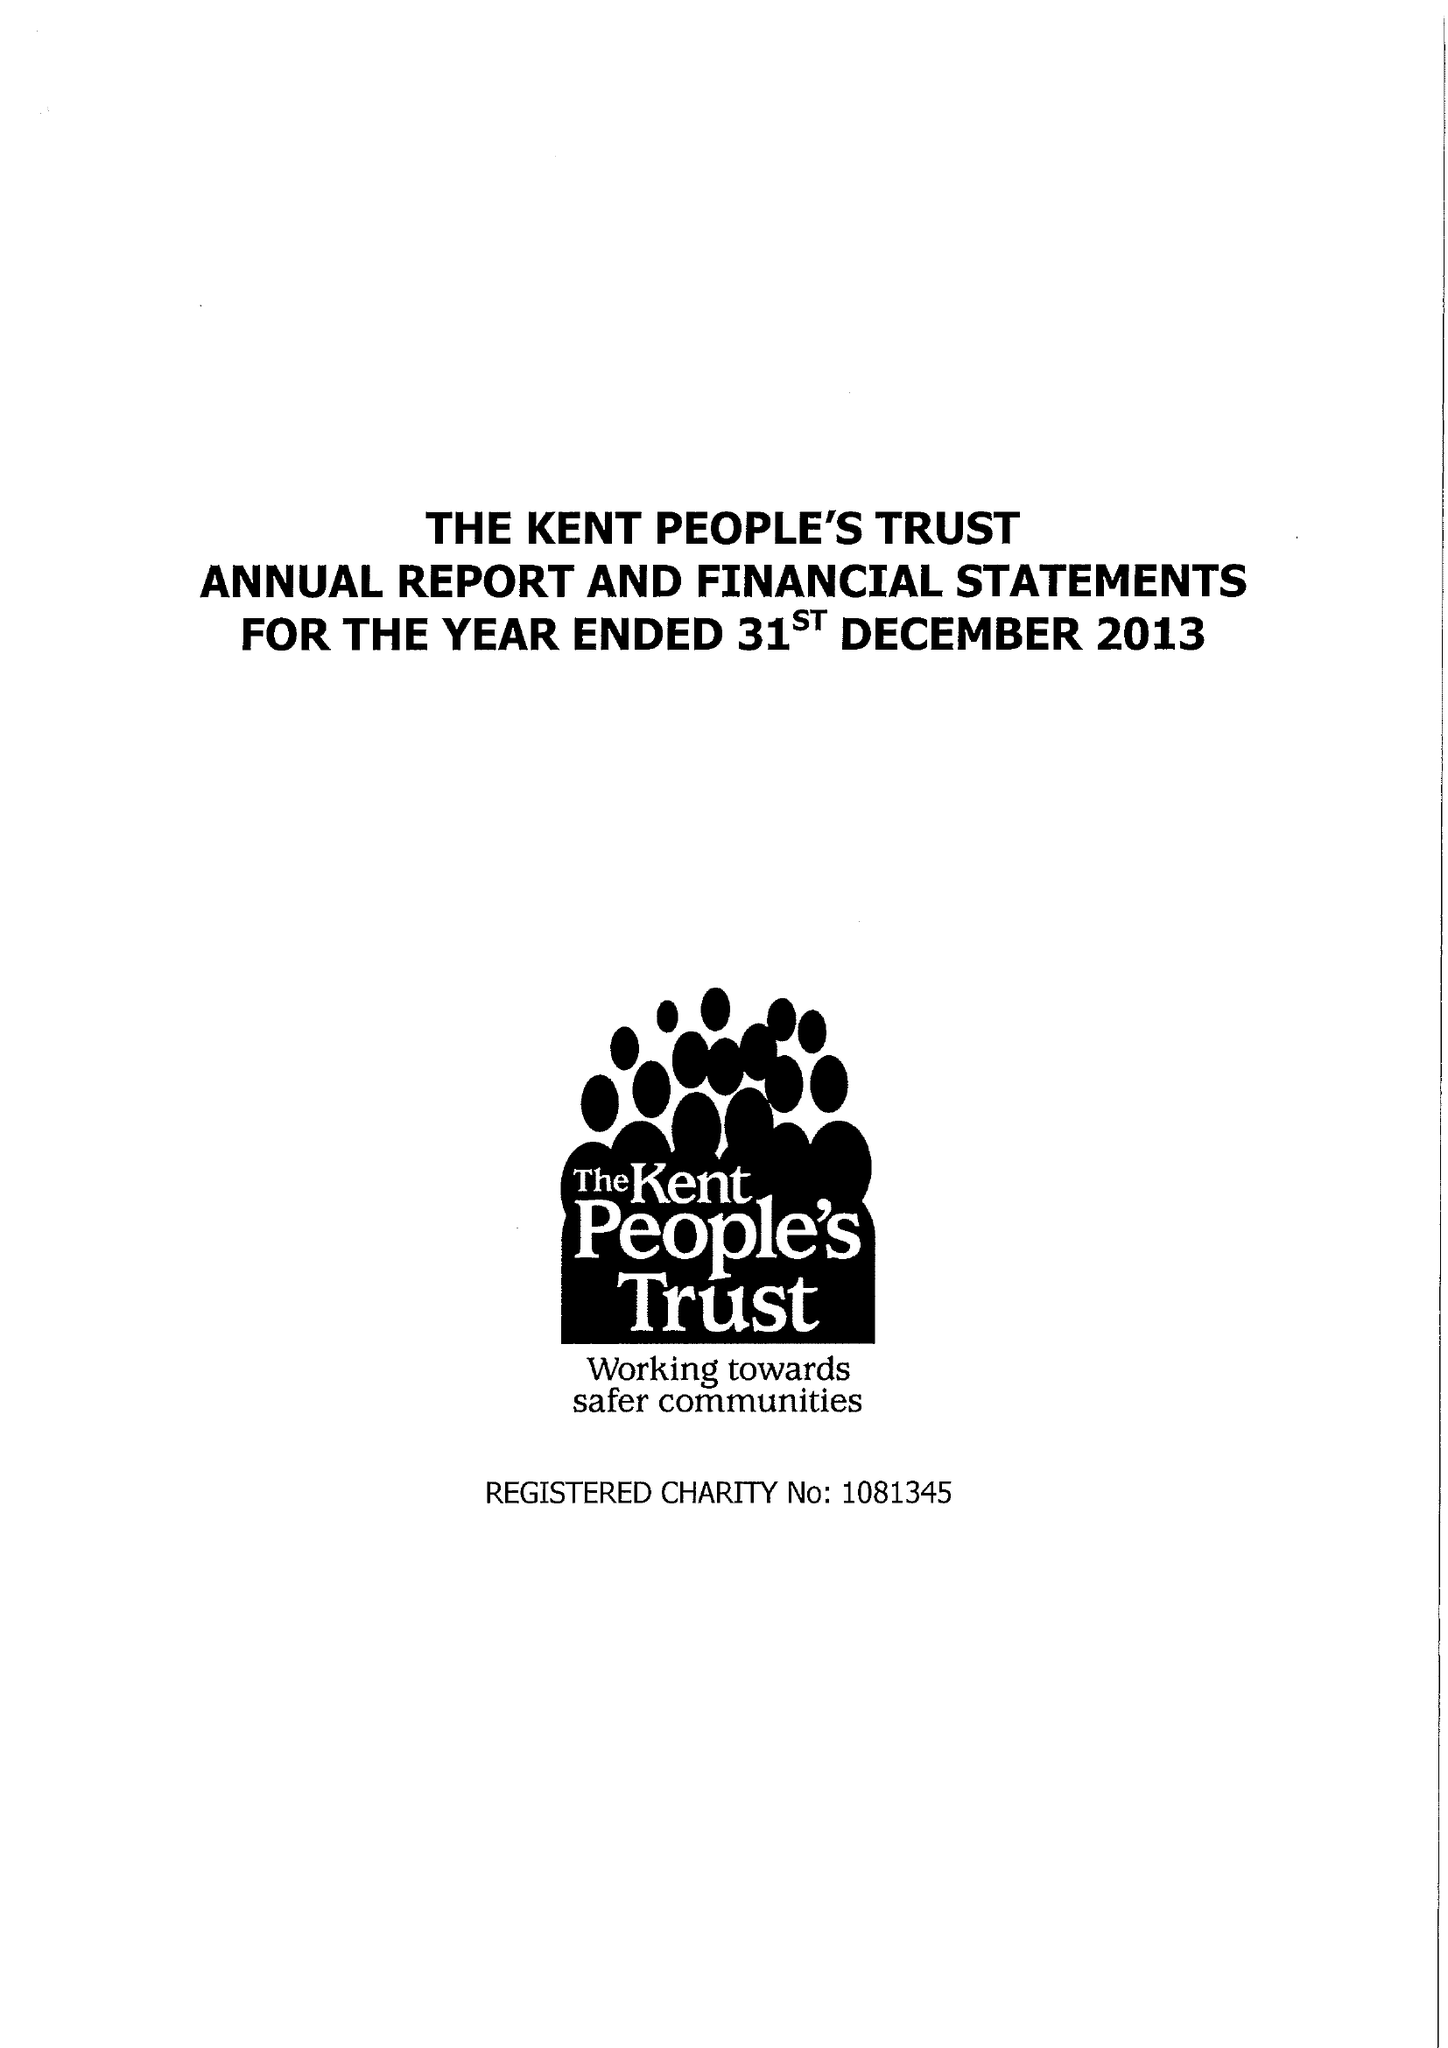What is the value for the address__postcode?
Answer the question using a single word or phrase. ME15 9BZ 